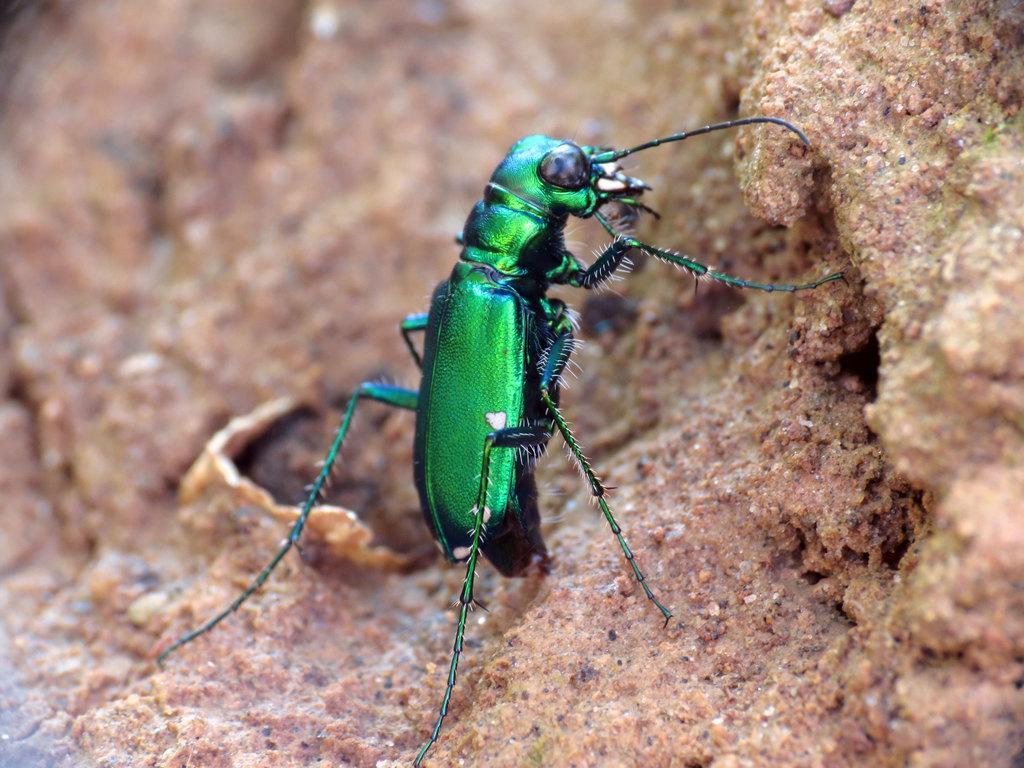Please provide a concise description of this image. In this picture there is an insect on the ground and the insect is in green color. 